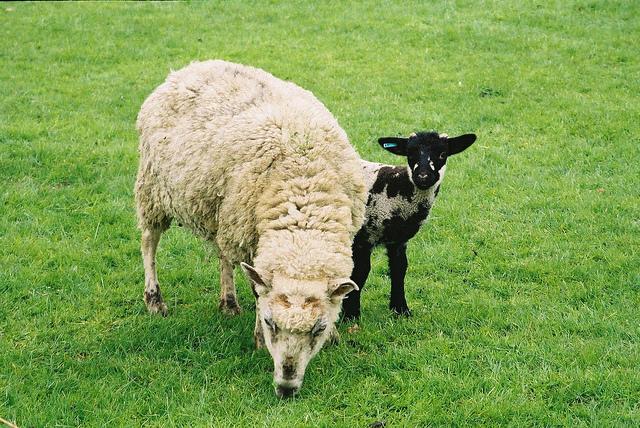How old is the baby sheep?
Give a very brief answer. 6 months. Is the large sheep the small sheep's mother?
Be succinct. Yes. How many sheep are in the image?
Be succinct. 2. How many sheep legs are visible in the photo?
Write a very short answer. 4. 